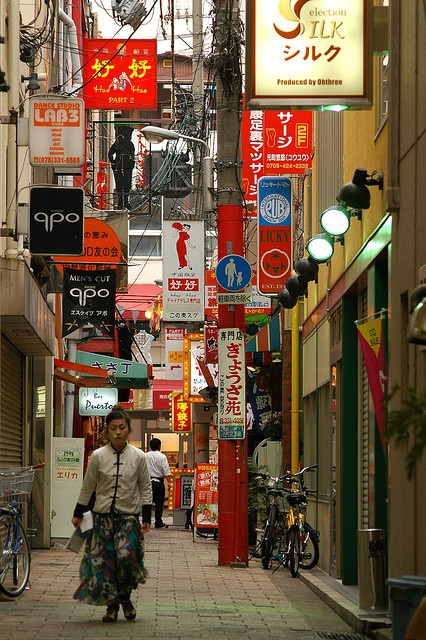Describe the objects in this image and their specific colors. I can see people in tan, black, gray, and maroon tones, traffic light in tan, black, white, gray, and darkgreen tones, bicycle in tan, black, and gray tones, bicycle in tan, black, darkgreen, gray, and maroon tones, and bicycle in tan, black, darkgreen, and gray tones in this image. 